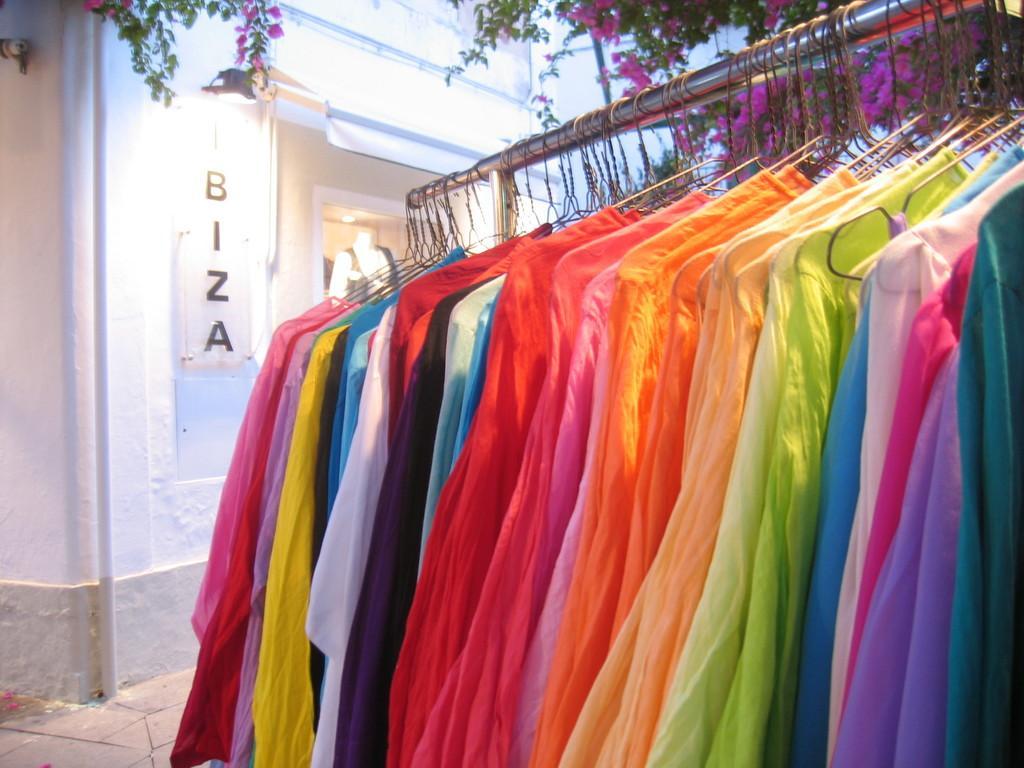Please provide a concise description of this image. In this image I can see number of colorful clothes are hanged to the metal rod. In the background I can see few trees, few pink colored flowers, a building, a light to the building and a mannequin. 